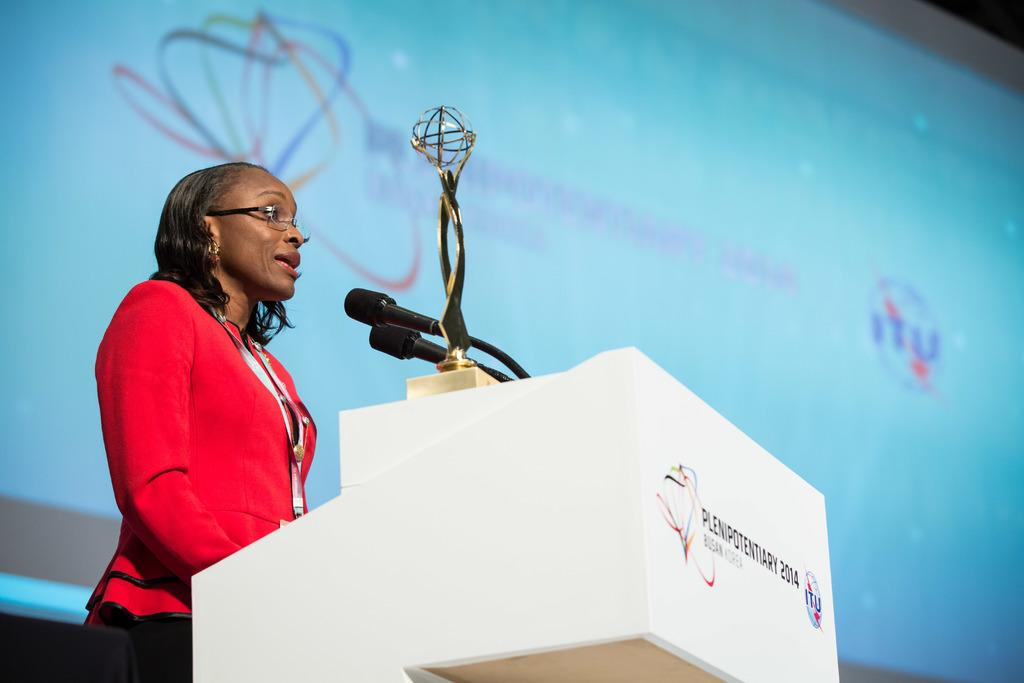What is the woman in the image wearing? The woman is wearing a red dress. What is in front of the woman in the image? There is a white color podium in front of the woman. What can be seen on the podium in the image? There are mice visible in the image. What is the color of the screen in the background of the image? The screen in the background of the image is blue. What object is the woman possibly receiving or holding in the image? There is a trophy in the image, which suggests the woman might be receiving or holding it. Where is the pot that the grandfather is using to fix the wrench in the image? There is no pot or grandfather present in the image, and no wrench is being fixed. 